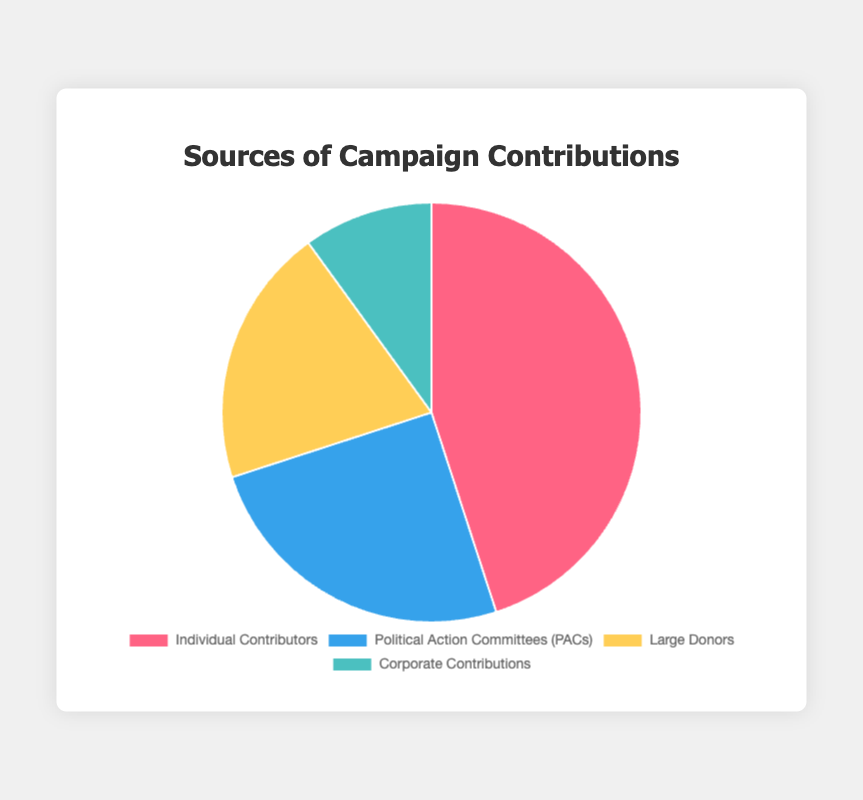what is the highest contribution source? The highest percentage on the pie chart is 45%, corresponding to Individual Contributors
Answer: Individual Contributors which source has the lowest contribution? The lowest percentage on the pie chart is 10%, corresponding to Corporate Contributions
Answer: Corporate Contributions how much more percentage do Individual Contributors contribute compared to Large Donors? Individual Contributors contribute 45%, and Large Donors contribute 20%. The difference is 45% - 20% = 25%
Answer: 25% how do the total contributions from PACs and Large Donors compare to Individual Contributors? PACs contribute 25% and Large Donors contribute 20%. Their combined contribution is 25% + 20% = 45%, which is the same as the contribution of Individual Contributors
Answer: the same if we aim to increase Large Donors to equal Individual Contributors' percentage, by how much percentage should it be increased? Large Donors contribute 20%, while Individual Contributors contribute 45%. The increase needed is 45% - 20% = 25%
Answer: 25% which contributions sources have a combined percentage higher than 30%? Individual Contributors at 45% and PACs at 25% are individually higher. Their combined percentage with any other source is still higher than 30%
Answer: Individual Contributors, PACs what is the average percentage of all sources? Sum all source percentages: 45% + 25% + 20% + 10% = 100%. There are 4 sources, so the average percentage is 100% / 4 = 25%
Answer: 25% which sources are represented by warm colors (e.g., red and yellow)? Red corresponds to Individual Contributors (45%) and yellow corresponds to Large Donors (20%) in the legend of the pie chart
Answer: Individual Contributors, Large Donors 